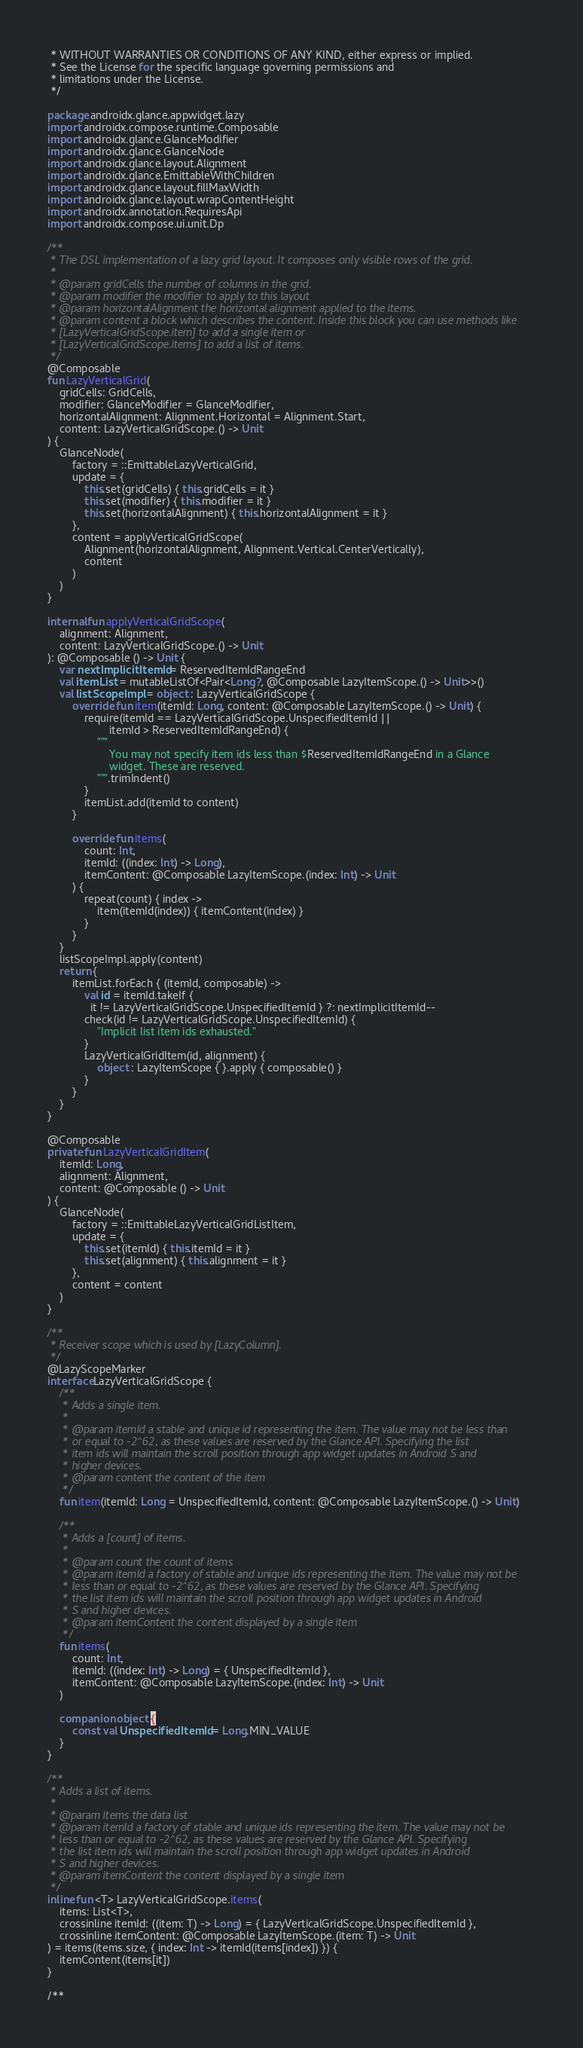Convert code to text. <code><loc_0><loc_0><loc_500><loc_500><_Kotlin_> * WITHOUT WARRANTIES OR CONDITIONS OF ANY KIND, either express or implied.
 * See the License for the specific language governing permissions and
 * limitations under the License.
 */

package androidx.glance.appwidget.lazy
import androidx.compose.runtime.Composable
import androidx.glance.GlanceModifier
import androidx.glance.GlanceNode
import androidx.glance.layout.Alignment
import androidx.glance.EmittableWithChildren
import androidx.glance.layout.fillMaxWidth
import androidx.glance.layout.wrapContentHeight
import androidx.annotation.RequiresApi
import androidx.compose.ui.unit.Dp

/**
 * The DSL implementation of a lazy grid layout. It composes only visible rows of the grid.
 *
 * @param gridCells the number of columns in the grid.
 * @param modifier the modifier to apply to this layout
 * @param horizontalAlignment the horizontal alignment applied to the items.
 * @param content a block which describes the content. Inside this block you can use methods like
 * [LazyVerticalGridScope.item] to add a single item or
 * [LazyVerticalGridScope.items] to add a list of items.
 */
@Composable
fun LazyVerticalGrid(
    gridCells: GridCells,
    modifier: GlanceModifier = GlanceModifier,
    horizontalAlignment: Alignment.Horizontal = Alignment.Start,
    content: LazyVerticalGridScope.() -> Unit
) {
    GlanceNode(
        factory = ::EmittableLazyVerticalGrid,
        update = {
            this.set(gridCells) { this.gridCells = it }
            this.set(modifier) { this.modifier = it }
            this.set(horizontalAlignment) { this.horizontalAlignment = it }
        },
        content = applyVerticalGridScope(
            Alignment(horizontalAlignment, Alignment.Vertical.CenterVertically),
            content
        )
    )
}

internal fun applyVerticalGridScope(
    alignment: Alignment,
    content: LazyVerticalGridScope.() -> Unit
): @Composable () -> Unit {
    var nextImplicitItemId = ReservedItemIdRangeEnd
    val itemList = mutableListOf<Pair<Long?, @Composable LazyItemScope.() -> Unit>>()
    val listScopeImpl = object : LazyVerticalGridScope {
        override fun item(itemId: Long, content: @Composable LazyItemScope.() -> Unit) {
            require(itemId == LazyVerticalGridScope.UnspecifiedItemId ||
                    itemId > ReservedItemIdRangeEnd) {
                """
                    You may not specify item ids less than $ReservedItemIdRangeEnd in a Glance
                    widget. These are reserved.
                """.trimIndent()
            }
            itemList.add(itemId to content)
        }

        override fun items(
            count: Int,
            itemId: ((index: Int) -> Long),
            itemContent: @Composable LazyItemScope.(index: Int) -> Unit
        ) {
            repeat(count) { index ->
                item(itemId(index)) { itemContent(index) }
            }
        }
    }
    listScopeImpl.apply(content)
    return {
        itemList.forEach { (itemId, composable) ->
            val id = itemId.takeIf {
              it != LazyVerticalGridScope.UnspecifiedItemId } ?: nextImplicitItemId--
            check(id != LazyVerticalGridScope.UnspecifiedItemId) {
                "Implicit list item ids exhausted."
            }
            LazyVerticalGridItem(id, alignment) {
                object : LazyItemScope { }.apply { composable() }
            }
        }
    }
}

@Composable
private fun LazyVerticalGridItem(
    itemId: Long,
    alignment: Alignment,
    content: @Composable () -> Unit
) {
    GlanceNode(
        factory = ::EmittableLazyVerticalGridListItem,
        update = {
            this.set(itemId) { this.itemId = it }
            this.set(alignment) { this.alignment = it }
        },
        content = content
    )
}

/**
 * Receiver scope which is used by [LazyColumn].
 */
@LazyScopeMarker
interface LazyVerticalGridScope {
    /**
     * Adds a single item.
     *
     * @param itemId a stable and unique id representing the item. The value may not be less than
     * or equal to -2^62, as these values are reserved by the Glance API. Specifying the list
     * item ids will maintain the scroll position through app widget updates in Android S and
     * higher devices.
     * @param content the content of the item
     */
    fun item(itemId: Long = UnspecifiedItemId, content: @Composable LazyItemScope.() -> Unit)

    /**
     * Adds a [count] of items.
     *
     * @param count the count of items
     * @param itemId a factory of stable and unique ids representing the item. The value may not be
     * less than or equal to -2^62, as these values are reserved by the Glance API. Specifying
     * the list item ids will maintain the scroll position through app widget updates in Android
     * S and higher devices.
     * @param itemContent the content displayed by a single item
     */
    fun items(
        count: Int,
        itemId: ((index: Int) -> Long) = { UnspecifiedItemId },
        itemContent: @Composable LazyItemScope.(index: Int) -> Unit
    )

    companion object {
        const val UnspecifiedItemId = Long.MIN_VALUE
    }
}

/**
 * Adds a list of items.
 *
 * @param items the data list
 * @param itemId a factory of stable and unique ids representing the item. The value may not be
 * less than or equal to -2^62, as these values are reserved by the Glance API. Specifying
 * the list item ids will maintain the scroll position through app widget updates in Android
 * S and higher devices.
 * @param itemContent the content displayed by a single item
 */
inline fun <T> LazyVerticalGridScope.items(
    items: List<T>,
    crossinline itemId: ((item: T) -> Long) = { LazyVerticalGridScope.UnspecifiedItemId },
    crossinline itemContent: @Composable LazyItemScope.(item: T) -> Unit
) = items(items.size, { index: Int -> itemId(items[index]) }) {
    itemContent(items[it])
}

/**</code> 